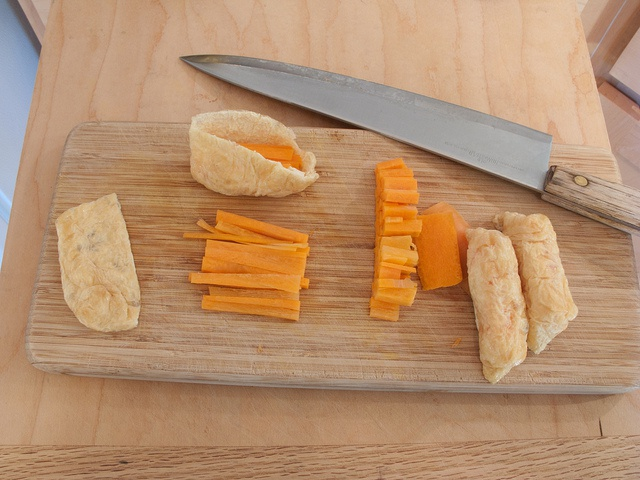Describe the objects in this image and their specific colors. I can see knife in gray and darkgray tones, carrot in gray, orange, and red tones, carrot in gray, orange, and red tones, sandwich in gray, tan, and orange tones, and sandwich in gray and tan tones in this image. 